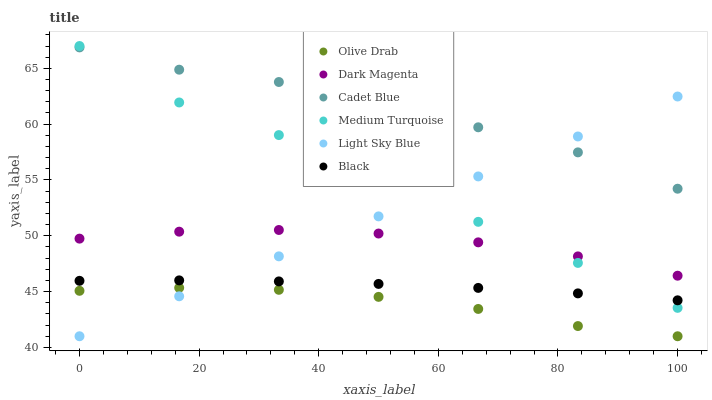Does Olive Drab have the minimum area under the curve?
Answer yes or no. Yes. Does Cadet Blue have the maximum area under the curve?
Answer yes or no. Yes. Does Dark Magenta have the minimum area under the curve?
Answer yes or no. No. Does Dark Magenta have the maximum area under the curve?
Answer yes or no. No. Is Light Sky Blue the smoothest?
Answer yes or no. Yes. Is Medium Turquoise the roughest?
Answer yes or no. Yes. Is Dark Magenta the smoothest?
Answer yes or no. No. Is Dark Magenta the roughest?
Answer yes or no. No. Does Light Sky Blue have the lowest value?
Answer yes or no. Yes. Does Dark Magenta have the lowest value?
Answer yes or no. No. Does Medium Turquoise have the highest value?
Answer yes or no. Yes. Does Dark Magenta have the highest value?
Answer yes or no. No. Is Olive Drab less than Black?
Answer yes or no. Yes. Is Cadet Blue greater than Olive Drab?
Answer yes or no. Yes. Does Dark Magenta intersect Light Sky Blue?
Answer yes or no. Yes. Is Dark Magenta less than Light Sky Blue?
Answer yes or no. No. Is Dark Magenta greater than Light Sky Blue?
Answer yes or no. No. Does Olive Drab intersect Black?
Answer yes or no. No. 